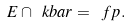Convert formula to latex. <formula><loc_0><loc_0><loc_500><loc_500>E \cap \ k b a r = \ f p .</formula> 